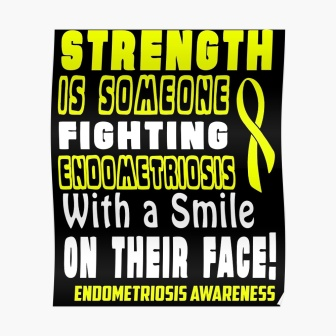Create a very creative question about the poster. If the yellow ribbon on the poster could speak, what words of encouragement do you think it would offer to those battling endometriosis? 